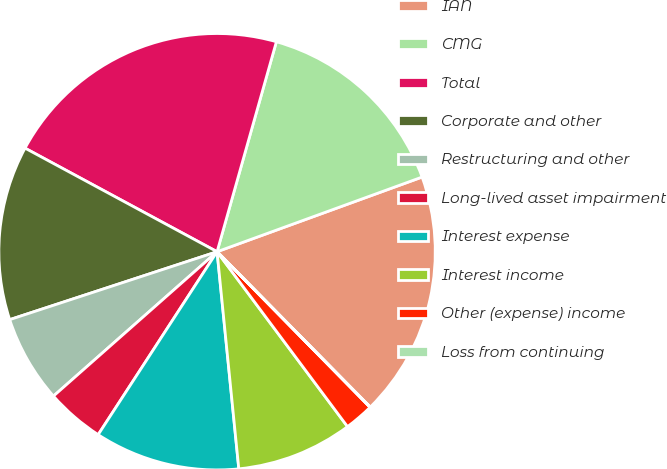Convert chart to OTSL. <chart><loc_0><loc_0><loc_500><loc_500><pie_chart><fcel>IAN<fcel>CMG<fcel>Total<fcel>Corporate and other<fcel>Restructuring and other<fcel>Long-lived asset impairment<fcel>Interest expense<fcel>Interest income<fcel>Other (expense) income<fcel>Loss from continuing<nl><fcel>18.17%<fcel>15.06%<fcel>21.51%<fcel>12.91%<fcel>6.47%<fcel>4.32%<fcel>10.76%<fcel>8.61%<fcel>2.17%<fcel>0.02%<nl></chart> 